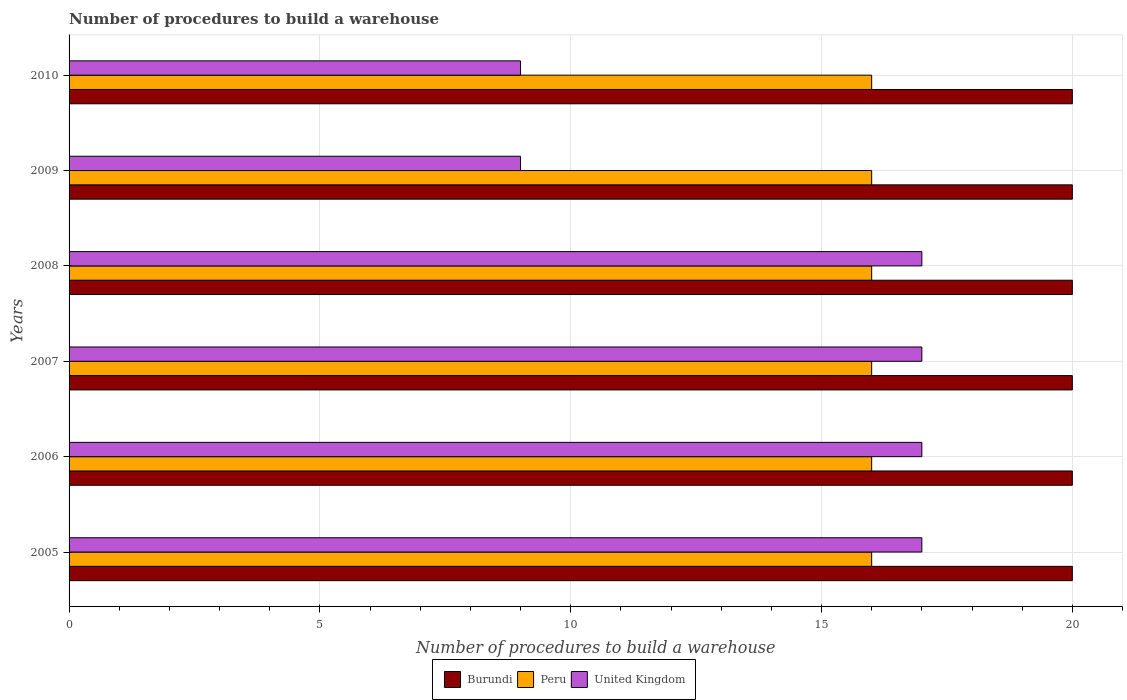How many different coloured bars are there?
Make the answer very short. 3. Are the number of bars per tick equal to the number of legend labels?
Keep it short and to the point. Yes. Are the number of bars on each tick of the Y-axis equal?
Offer a terse response. Yes. How many bars are there on the 5th tick from the bottom?
Keep it short and to the point. 3. In how many cases, is the number of bars for a given year not equal to the number of legend labels?
Your answer should be compact. 0. What is the number of procedures to build a warehouse in in Burundi in 2007?
Give a very brief answer. 20. Across all years, what is the maximum number of procedures to build a warehouse in in Burundi?
Offer a terse response. 20. Across all years, what is the minimum number of procedures to build a warehouse in in United Kingdom?
Make the answer very short. 9. What is the total number of procedures to build a warehouse in in Peru in the graph?
Give a very brief answer. 96. What is the difference between the number of procedures to build a warehouse in in Peru in 2006 and the number of procedures to build a warehouse in in Burundi in 2007?
Give a very brief answer. -4. In the year 2009, what is the difference between the number of procedures to build a warehouse in in United Kingdom and number of procedures to build a warehouse in in Peru?
Keep it short and to the point. -7. In how many years, is the number of procedures to build a warehouse in in Peru greater than 7 ?
Ensure brevity in your answer.  6. What is the ratio of the number of procedures to build a warehouse in in United Kingdom in 2008 to that in 2009?
Offer a terse response. 1.89. What is the difference between the highest and the second highest number of procedures to build a warehouse in in Peru?
Give a very brief answer. 0. In how many years, is the number of procedures to build a warehouse in in Peru greater than the average number of procedures to build a warehouse in in Peru taken over all years?
Your response must be concise. 0. What does the 3rd bar from the bottom in 2006 represents?
Your answer should be compact. United Kingdom. How many bars are there?
Ensure brevity in your answer.  18. How many years are there in the graph?
Your answer should be compact. 6. How are the legend labels stacked?
Your response must be concise. Horizontal. What is the title of the graph?
Your response must be concise. Number of procedures to build a warehouse. Does "Channel Islands" appear as one of the legend labels in the graph?
Ensure brevity in your answer.  No. What is the label or title of the X-axis?
Your answer should be compact. Number of procedures to build a warehouse. What is the label or title of the Y-axis?
Your response must be concise. Years. What is the Number of procedures to build a warehouse of Burundi in 2005?
Make the answer very short. 20. What is the Number of procedures to build a warehouse of Peru in 2005?
Offer a terse response. 16. What is the Number of procedures to build a warehouse in United Kingdom in 2005?
Provide a succinct answer. 17. What is the Number of procedures to build a warehouse in Burundi in 2006?
Your response must be concise. 20. What is the Number of procedures to build a warehouse in United Kingdom in 2006?
Make the answer very short. 17. What is the Number of procedures to build a warehouse of Burundi in 2007?
Offer a terse response. 20. What is the Number of procedures to build a warehouse of Burundi in 2008?
Offer a very short reply. 20. What is the Number of procedures to build a warehouse in Burundi in 2009?
Offer a terse response. 20. What is the Number of procedures to build a warehouse in Peru in 2009?
Offer a terse response. 16. What is the Number of procedures to build a warehouse in Burundi in 2010?
Offer a terse response. 20. What is the Number of procedures to build a warehouse in Peru in 2010?
Your answer should be compact. 16. What is the Number of procedures to build a warehouse in United Kingdom in 2010?
Offer a terse response. 9. Across all years, what is the maximum Number of procedures to build a warehouse in Peru?
Offer a terse response. 16. Across all years, what is the minimum Number of procedures to build a warehouse in Peru?
Give a very brief answer. 16. What is the total Number of procedures to build a warehouse in Burundi in the graph?
Your answer should be very brief. 120. What is the total Number of procedures to build a warehouse of Peru in the graph?
Your answer should be compact. 96. What is the difference between the Number of procedures to build a warehouse in Burundi in 2005 and that in 2006?
Ensure brevity in your answer.  0. What is the difference between the Number of procedures to build a warehouse in United Kingdom in 2005 and that in 2006?
Offer a terse response. 0. What is the difference between the Number of procedures to build a warehouse of Burundi in 2005 and that in 2007?
Make the answer very short. 0. What is the difference between the Number of procedures to build a warehouse in Peru in 2005 and that in 2007?
Ensure brevity in your answer.  0. What is the difference between the Number of procedures to build a warehouse in United Kingdom in 2005 and that in 2007?
Offer a terse response. 0. What is the difference between the Number of procedures to build a warehouse in Peru in 2005 and that in 2008?
Make the answer very short. 0. What is the difference between the Number of procedures to build a warehouse of Peru in 2005 and that in 2009?
Give a very brief answer. 0. What is the difference between the Number of procedures to build a warehouse of Burundi in 2005 and that in 2010?
Your answer should be very brief. 0. What is the difference between the Number of procedures to build a warehouse in United Kingdom in 2005 and that in 2010?
Provide a succinct answer. 8. What is the difference between the Number of procedures to build a warehouse of Burundi in 2006 and that in 2007?
Keep it short and to the point. 0. What is the difference between the Number of procedures to build a warehouse of Peru in 2006 and that in 2007?
Provide a short and direct response. 0. What is the difference between the Number of procedures to build a warehouse of United Kingdom in 2006 and that in 2007?
Your answer should be compact. 0. What is the difference between the Number of procedures to build a warehouse in United Kingdom in 2006 and that in 2008?
Your response must be concise. 0. What is the difference between the Number of procedures to build a warehouse in United Kingdom in 2006 and that in 2009?
Keep it short and to the point. 8. What is the difference between the Number of procedures to build a warehouse in Burundi in 2006 and that in 2010?
Give a very brief answer. 0. What is the difference between the Number of procedures to build a warehouse of United Kingdom in 2006 and that in 2010?
Make the answer very short. 8. What is the difference between the Number of procedures to build a warehouse in Burundi in 2007 and that in 2008?
Keep it short and to the point. 0. What is the difference between the Number of procedures to build a warehouse of Peru in 2007 and that in 2008?
Your answer should be very brief. 0. What is the difference between the Number of procedures to build a warehouse in Burundi in 2007 and that in 2009?
Your response must be concise. 0. What is the difference between the Number of procedures to build a warehouse of Peru in 2007 and that in 2009?
Your answer should be compact. 0. What is the difference between the Number of procedures to build a warehouse of Burundi in 2007 and that in 2010?
Ensure brevity in your answer.  0. What is the difference between the Number of procedures to build a warehouse in Burundi in 2008 and that in 2009?
Make the answer very short. 0. What is the difference between the Number of procedures to build a warehouse in United Kingdom in 2008 and that in 2010?
Your answer should be compact. 8. What is the difference between the Number of procedures to build a warehouse of Burundi in 2009 and that in 2010?
Your answer should be compact. 0. What is the difference between the Number of procedures to build a warehouse of Peru in 2009 and that in 2010?
Give a very brief answer. 0. What is the difference between the Number of procedures to build a warehouse in Burundi in 2005 and the Number of procedures to build a warehouse in Peru in 2006?
Give a very brief answer. 4. What is the difference between the Number of procedures to build a warehouse of Burundi in 2005 and the Number of procedures to build a warehouse of United Kingdom in 2006?
Your response must be concise. 3. What is the difference between the Number of procedures to build a warehouse in Peru in 2005 and the Number of procedures to build a warehouse in United Kingdom in 2006?
Offer a terse response. -1. What is the difference between the Number of procedures to build a warehouse in Burundi in 2005 and the Number of procedures to build a warehouse in Peru in 2007?
Provide a short and direct response. 4. What is the difference between the Number of procedures to build a warehouse of Burundi in 2005 and the Number of procedures to build a warehouse of United Kingdom in 2007?
Provide a short and direct response. 3. What is the difference between the Number of procedures to build a warehouse of Peru in 2005 and the Number of procedures to build a warehouse of United Kingdom in 2007?
Offer a very short reply. -1. What is the difference between the Number of procedures to build a warehouse in Burundi in 2005 and the Number of procedures to build a warehouse in United Kingdom in 2008?
Make the answer very short. 3. What is the difference between the Number of procedures to build a warehouse in Peru in 2005 and the Number of procedures to build a warehouse in United Kingdom in 2008?
Provide a short and direct response. -1. What is the difference between the Number of procedures to build a warehouse of Peru in 2005 and the Number of procedures to build a warehouse of United Kingdom in 2010?
Ensure brevity in your answer.  7. What is the difference between the Number of procedures to build a warehouse in Burundi in 2006 and the Number of procedures to build a warehouse in Peru in 2007?
Your answer should be very brief. 4. What is the difference between the Number of procedures to build a warehouse of Burundi in 2006 and the Number of procedures to build a warehouse of Peru in 2008?
Make the answer very short. 4. What is the difference between the Number of procedures to build a warehouse in Burundi in 2006 and the Number of procedures to build a warehouse in United Kingdom in 2010?
Provide a succinct answer. 11. What is the difference between the Number of procedures to build a warehouse of Peru in 2006 and the Number of procedures to build a warehouse of United Kingdom in 2010?
Your answer should be compact. 7. What is the difference between the Number of procedures to build a warehouse of Burundi in 2007 and the Number of procedures to build a warehouse of Peru in 2008?
Give a very brief answer. 4. What is the difference between the Number of procedures to build a warehouse in Burundi in 2007 and the Number of procedures to build a warehouse in United Kingdom in 2008?
Your response must be concise. 3. What is the difference between the Number of procedures to build a warehouse in Burundi in 2007 and the Number of procedures to build a warehouse in Peru in 2009?
Keep it short and to the point. 4. What is the difference between the Number of procedures to build a warehouse of Peru in 2007 and the Number of procedures to build a warehouse of United Kingdom in 2009?
Keep it short and to the point. 7. What is the difference between the Number of procedures to build a warehouse of Burundi in 2008 and the Number of procedures to build a warehouse of United Kingdom in 2009?
Your response must be concise. 11. What is the difference between the Number of procedures to build a warehouse of Burundi in 2008 and the Number of procedures to build a warehouse of United Kingdom in 2010?
Ensure brevity in your answer.  11. What is the difference between the Number of procedures to build a warehouse in Peru in 2009 and the Number of procedures to build a warehouse in United Kingdom in 2010?
Provide a short and direct response. 7. What is the average Number of procedures to build a warehouse of Burundi per year?
Ensure brevity in your answer.  20. What is the average Number of procedures to build a warehouse of Peru per year?
Offer a very short reply. 16. What is the average Number of procedures to build a warehouse in United Kingdom per year?
Provide a short and direct response. 14.33. In the year 2005, what is the difference between the Number of procedures to build a warehouse in Burundi and Number of procedures to build a warehouse in United Kingdom?
Your answer should be compact. 3. In the year 2006, what is the difference between the Number of procedures to build a warehouse of Burundi and Number of procedures to build a warehouse of United Kingdom?
Ensure brevity in your answer.  3. In the year 2006, what is the difference between the Number of procedures to build a warehouse in Peru and Number of procedures to build a warehouse in United Kingdom?
Offer a terse response. -1. In the year 2007, what is the difference between the Number of procedures to build a warehouse of Peru and Number of procedures to build a warehouse of United Kingdom?
Provide a succinct answer. -1. In the year 2008, what is the difference between the Number of procedures to build a warehouse in Burundi and Number of procedures to build a warehouse in United Kingdom?
Your answer should be compact. 3. In the year 2009, what is the difference between the Number of procedures to build a warehouse in Burundi and Number of procedures to build a warehouse in Peru?
Offer a terse response. 4. In the year 2010, what is the difference between the Number of procedures to build a warehouse of Burundi and Number of procedures to build a warehouse of Peru?
Offer a terse response. 4. In the year 2010, what is the difference between the Number of procedures to build a warehouse in Burundi and Number of procedures to build a warehouse in United Kingdom?
Your answer should be compact. 11. What is the ratio of the Number of procedures to build a warehouse in Peru in 2005 to that in 2006?
Provide a short and direct response. 1. What is the ratio of the Number of procedures to build a warehouse in United Kingdom in 2005 to that in 2006?
Keep it short and to the point. 1. What is the ratio of the Number of procedures to build a warehouse of Burundi in 2005 to that in 2007?
Your answer should be very brief. 1. What is the ratio of the Number of procedures to build a warehouse of Peru in 2005 to that in 2007?
Give a very brief answer. 1. What is the ratio of the Number of procedures to build a warehouse in United Kingdom in 2005 to that in 2007?
Ensure brevity in your answer.  1. What is the ratio of the Number of procedures to build a warehouse of Peru in 2005 to that in 2008?
Your answer should be very brief. 1. What is the ratio of the Number of procedures to build a warehouse in Burundi in 2005 to that in 2009?
Offer a terse response. 1. What is the ratio of the Number of procedures to build a warehouse of United Kingdom in 2005 to that in 2009?
Provide a succinct answer. 1.89. What is the ratio of the Number of procedures to build a warehouse of Burundi in 2005 to that in 2010?
Your answer should be compact. 1. What is the ratio of the Number of procedures to build a warehouse in Peru in 2005 to that in 2010?
Make the answer very short. 1. What is the ratio of the Number of procedures to build a warehouse in United Kingdom in 2005 to that in 2010?
Provide a succinct answer. 1.89. What is the ratio of the Number of procedures to build a warehouse in Peru in 2006 to that in 2007?
Keep it short and to the point. 1. What is the ratio of the Number of procedures to build a warehouse in United Kingdom in 2006 to that in 2007?
Ensure brevity in your answer.  1. What is the ratio of the Number of procedures to build a warehouse of Burundi in 2006 to that in 2009?
Make the answer very short. 1. What is the ratio of the Number of procedures to build a warehouse of United Kingdom in 2006 to that in 2009?
Ensure brevity in your answer.  1.89. What is the ratio of the Number of procedures to build a warehouse of Burundi in 2006 to that in 2010?
Provide a succinct answer. 1. What is the ratio of the Number of procedures to build a warehouse in Peru in 2006 to that in 2010?
Your response must be concise. 1. What is the ratio of the Number of procedures to build a warehouse in United Kingdom in 2006 to that in 2010?
Offer a terse response. 1.89. What is the ratio of the Number of procedures to build a warehouse in Peru in 2007 to that in 2008?
Your answer should be very brief. 1. What is the ratio of the Number of procedures to build a warehouse in Peru in 2007 to that in 2009?
Your answer should be compact. 1. What is the ratio of the Number of procedures to build a warehouse in United Kingdom in 2007 to that in 2009?
Give a very brief answer. 1.89. What is the ratio of the Number of procedures to build a warehouse of Burundi in 2007 to that in 2010?
Provide a succinct answer. 1. What is the ratio of the Number of procedures to build a warehouse of United Kingdom in 2007 to that in 2010?
Give a very brief answer. 1.89. What is the ratio of the Number of procedures to build a warehouse of Peru in 2008 to that in 2009?
Your response must be concise. 1. What is the ratio of the Number of procedures to build a warehouse of United Kingdom in 2008 to that in 2009?
Make the answer very short. 1.89. What is the ratio of the Number of procedures to build a warehouse of Burundi in 2008 to that in 2010?
Make the answer very short. 1. What is the ratio of the Number of procedures to build a warehouse in United Kingdom in 2008 to that in 2010?
Your response must be concise. 1.89. What is the difference between the highest and the second highest Number of procedures to build a warehouse of Burundi?
Offer a terse response. 0. What is the difference between the highest and the second highest Number of procedures to build a warehouse of Peru?
Your answer should be very brief. 0. What is the difference between the highest and the second highest Number of procedures to build a warehouse of United Kingdom?
Your response must be concise. 0. What is the difference between the highest and the lowest Number of procedures to build a warehouse in Peru?
Provide a succinct answer. 0. What is the difference between the highest and the lowest Number of procedures to build a warehouse in United Kingdom?
Provide a succinct answer. 8. 